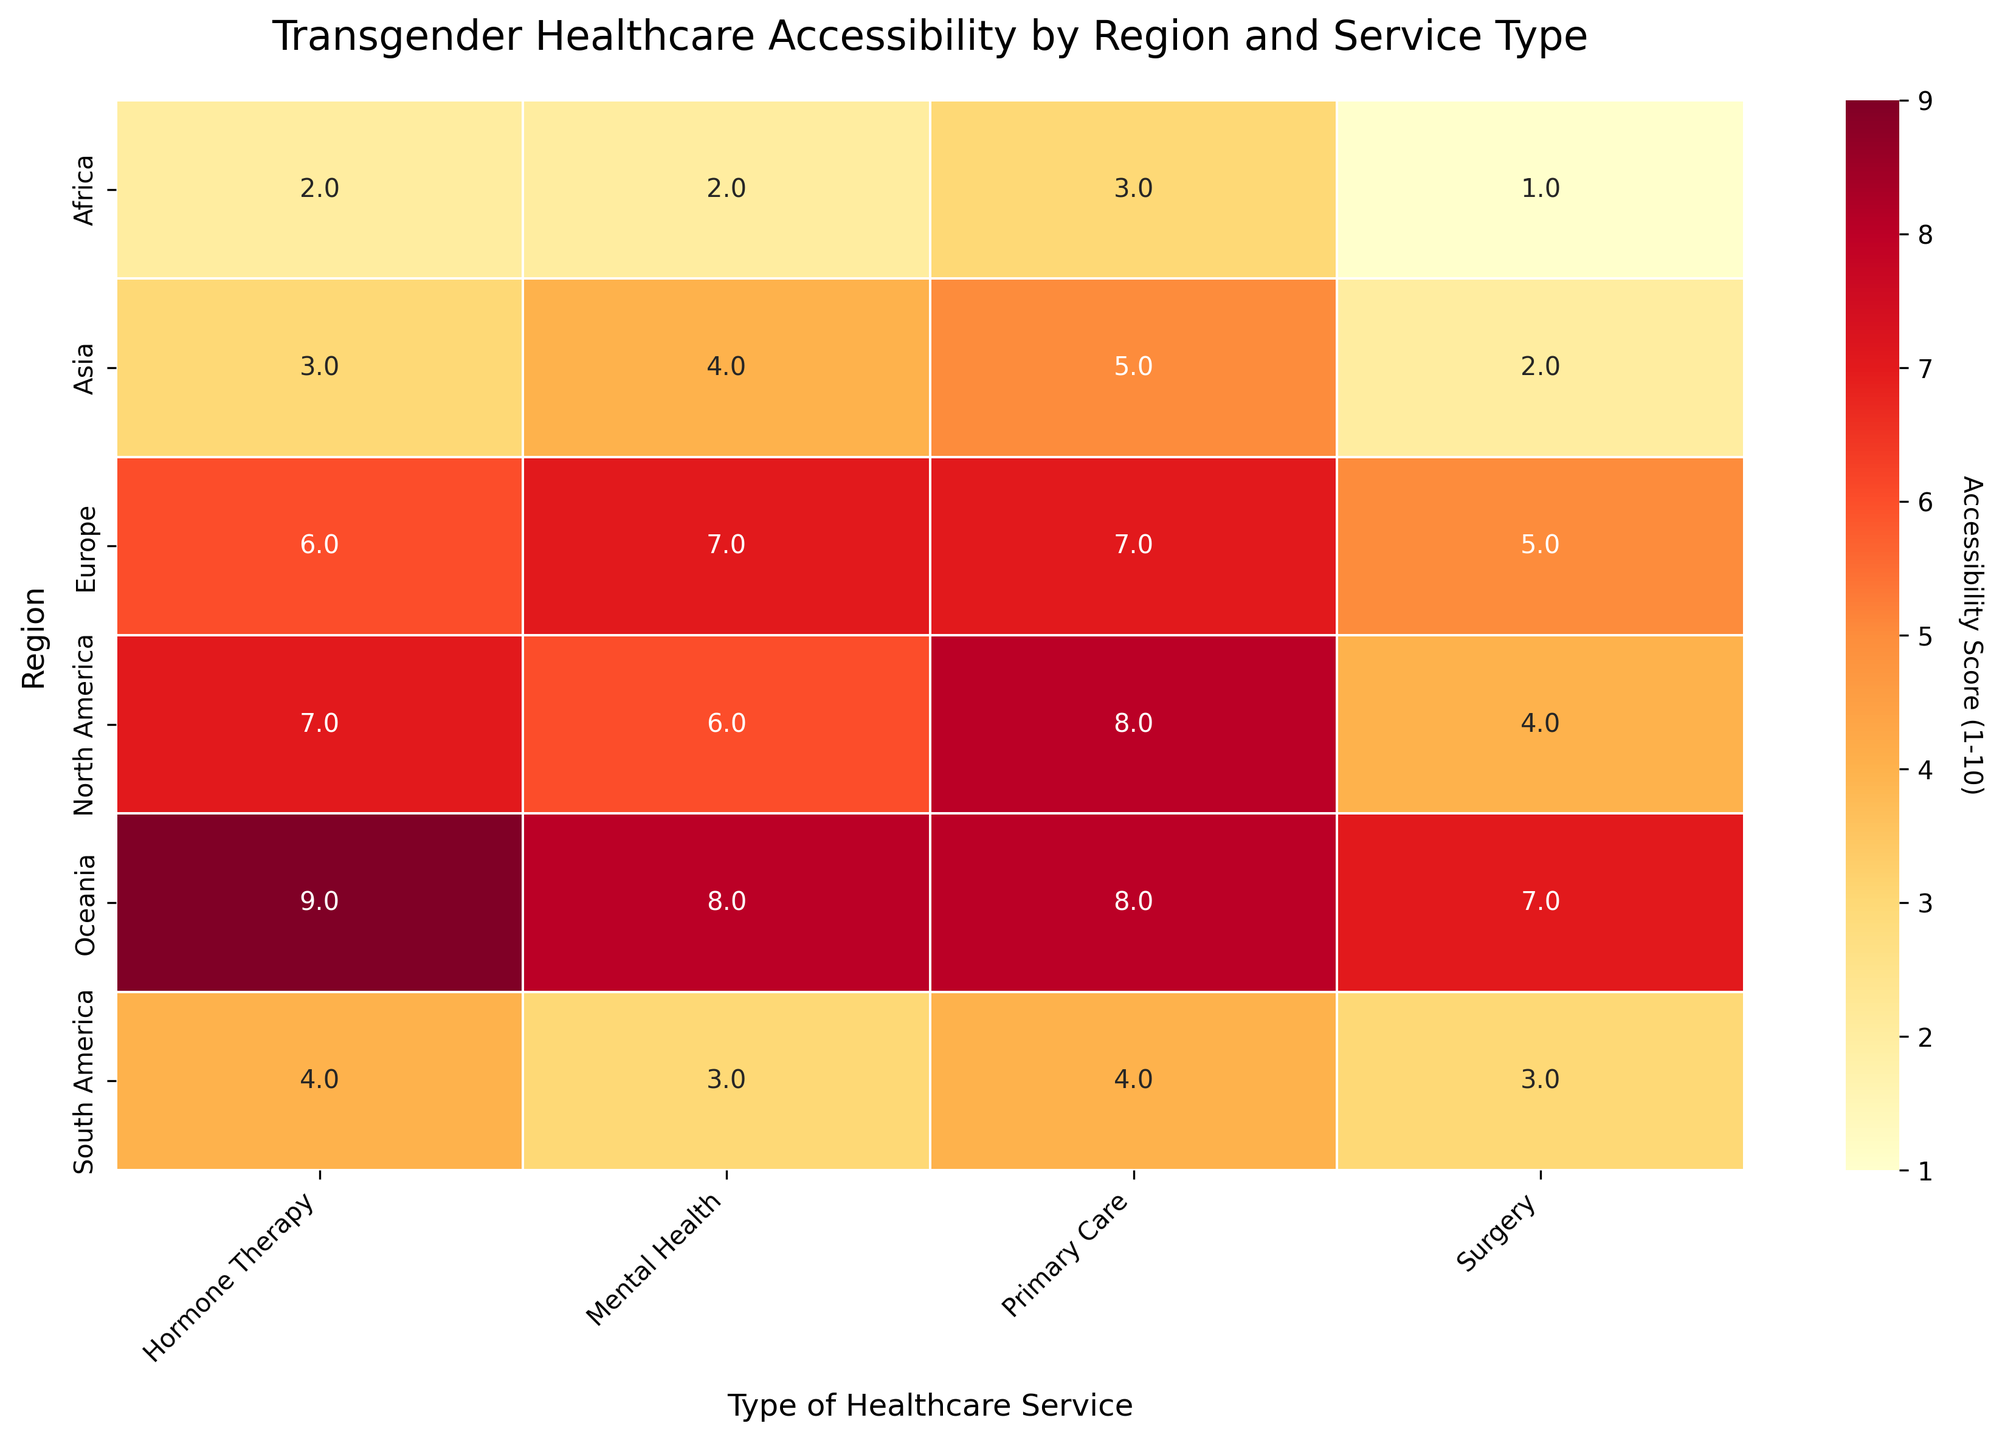What is the title of the heatmap? The title is prominently displayed at the top of the heatmap, giving a concise summary of what the figure represents.
Answer: Transgender Healthcare Accessibility by Region and Service Type Which region has the highest accessibility score for mental health services? Look at the column labeled "Mental Health" and find the highest number in that column.
Answer: Oceania How many types of healthcare services are compared in this heatmap? Count the distinct categories on the x-axis of the heatmap.
Answer: 4 What is the accessibility score for hormone therapy in Asia? Find the intersection of the "Asia" row and the "Hormone Therapy" column in the heatmap.
Answer: 3 Which healthcare service has the lowest overall accessibility score across all regions? Compare the accessibility scores for each type of healthcare service across all regions and find the minimum value.
Answer: Surgery What is the difference in accessibility scores for primary care between North America and South America? Find the accessibility scores for primary care in North America and South America, then compute their difference: 8 (North America) - 4 (South America).
Answer: 4 In which region is the accessibility score for surgery twice that of primary care? Compare the accessibility scores for surgery and primary care across all regions and check if any region's surgery score is double its primary care score. No such region exists, as none of the regions fulfill this condition (4, 5, 2, 3, 1, 7 for surgery & 8, 7, 5, 4, 3, 8 for primary care).
Answer: None What is the average accessibility score for hormone therapy across all regions? Sum the accessibility scores for hormone therapy across all regions and divide by the number of regions: (7+6+3+4+2+9) = 31. The average is 31/6.
Answer: 5.17 Which region shows the highest variation in accessibility scores among different types of healthcare services? Calculate the range (difference between the maximum and minimum values) of accessibility scores for each region and determine which region has the highest range. Europe: 7-5 = 2, North America: 8-4 = 4, Asia: 5-2 = 3, South America: 4-3 =1, Africa: 3-1 = 2, Oceania: 9-7 = 2
Answer: North America How does the accessibility score for primary care in Africa compare to the other services in the same region? Find the accessibility score for primary care in Africa and compare it with the scores for mental health, hormone therapy, and surgery in Africa. Primary care in Africa is 3, while mental health is 2, hormone therapy is 2, and surgery is 1. Primary care has the highest score in Africa.
Answer: Highest 